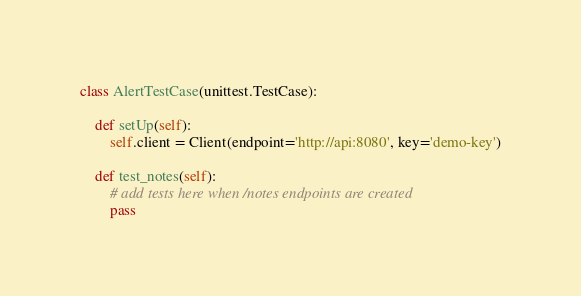<code> <loc_0><loc_0><loc_500><loc_500><_Python_>
class AlertTestCase(unittest.TestCase):

    def setUp(self):
        self.client = Client(endpoint='http://api:8080', key='demo-key')

    def test_notes(self):
        # add tests here when /notes endpoints are created
        pass
</code> 